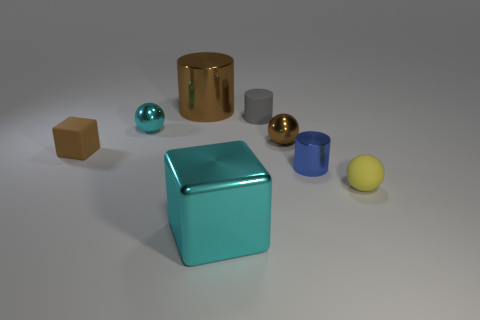Does the tiny yellow ball have the same material as the object in front of the yellow matte sphere?
Give a very brief answer. No. Are there more small brown matte blocks than blocks?
Ensure brevity in your answer.  No. What number of cylinders are either cyan matte things or brown metal objects?
Your answer should be very brief. 1. What is the color of the rubber cylinder?
Make the answer very short. Gray. Is the size of the cyan thing that is in front of the tiny yellow matte thing the same as the brown metal thing that is to the left of the gray rubber cylinder?
Ensure brevity in your answer.  Yes. Are there fewer small cyan shiny cubes than large cyan metal cubes?
Provide a succinct answer. Yes. There is a big metal block; how many metallic balls are to the right of it?
Provide a short and direct response. 1. What is the material of the small cube?
Make the answer very short. Rubber. Does the matte cube have the same color as the rubber cylinder?
Your answer should be very brief. No. Is the number of tiny yellow rubber objects that are left of the brown metal cylinder less than the number of large cylinders?
Your answer should be very brief. Yes. 